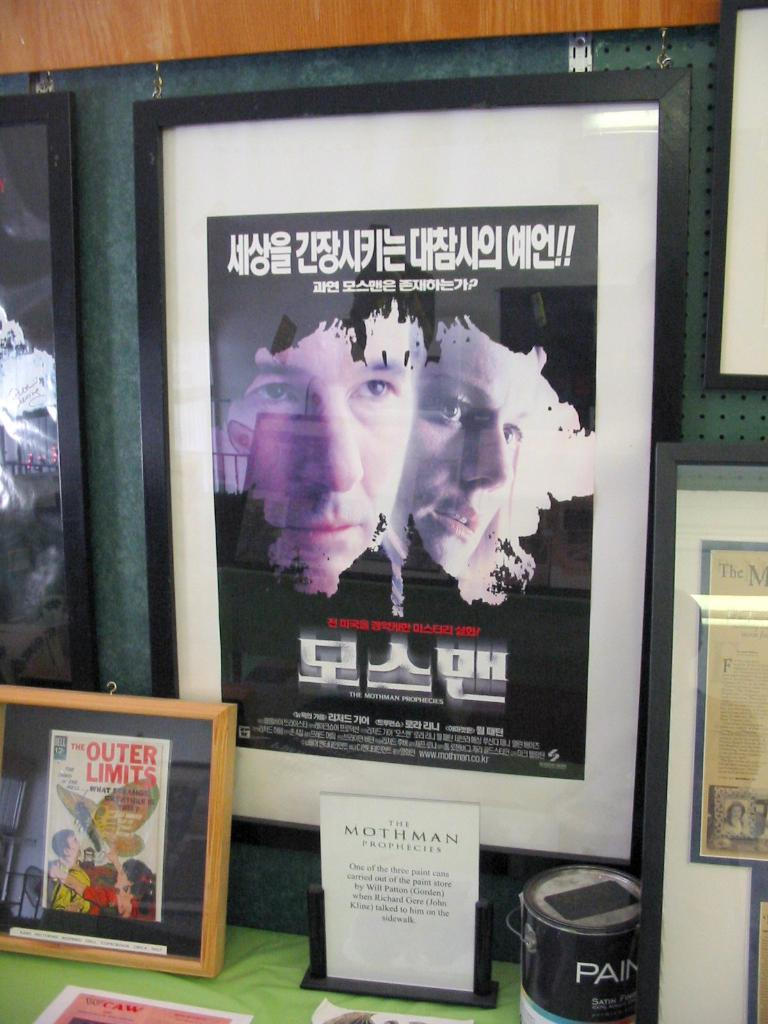Provide a one-sentence caption for the provided image. A display of framed collectibles, including something from the Outer Limits. 